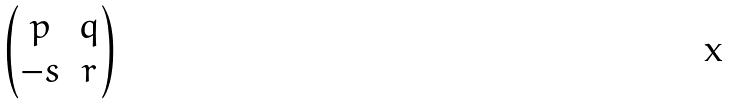Convert formula to latex. <formula><loc_0><loc_0><loc_500><loc_500>\begin{pmatrix} p & q \\ - s & r \end{pmatrix}</formula> 